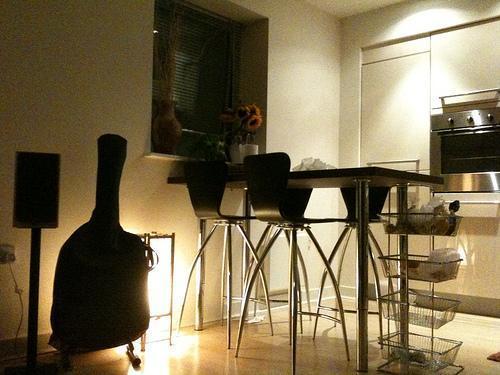How many animals in the picture?
Give a very brief answer. 0. How many chairs are there?
Give a very brief answer. 2. 